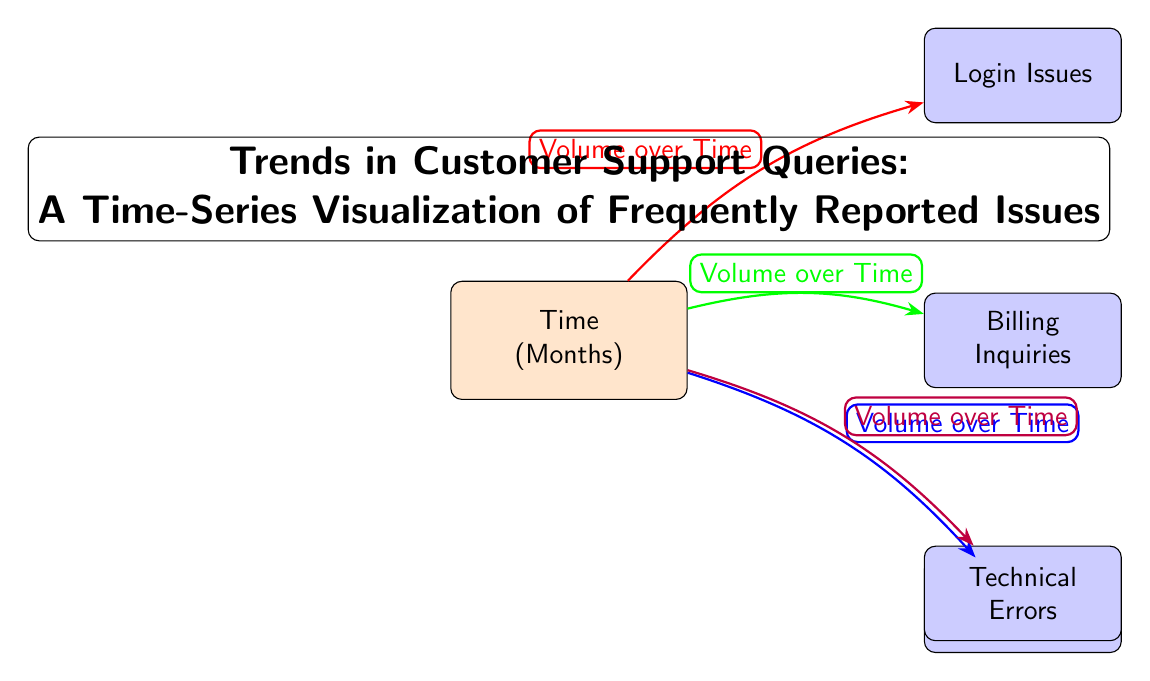What is the primary focus of the diagram? The diagram focuses on "Trends in Customer Support Queries," specifically visualizing the volume of frequently reported issues over time.
Answer: Trends in Customer Support Queries How many main issue categories are represented in the diagram? There are four main issue categories represented: Login Issues, Billing Inquiries, Feature Requests, and Technical Errors.
Answer: 4 Which issue is located directly above the "Time" node? The "Login Issues" node is located directly above the "Time" node, indicating it is a primary concern related to customer support queries.
Answer: Login Issues What color is used to represent "Feature Requests" in the diagram? The "Feature Requests" node is colored blue, differentiating it from other issues visually within the diagram.
Answer: Blue Which issue has the longest direct edge from the "Time" node based on the visual representation? The "Billing Inquiries" issue has a longer edge drawn from the "Time" node compared to others, indicating a possibly higher volume over time.
Answer: Billing Inquiries How is the relationship between "Time" and "Technical Errors" visualized in the diagram? The relationship is visualized with a purple arrow pointing from the "Time" node to "Technical Errors," indicating the volume of these errors over the specified time period.
Answer: Purple arrow If the volume of "Login Issues" increases, what might that imply about customer experiences? An increase in "Login Issues" may imply that users are facing more access issues, potentially affecting their overall satisfaction and the usability of the service.
Answer: More access issues Which edge color corresponds to "Billing Inquiries"? The edge color corresponding to "Billing Inquiries" is green, signifying that this category of customer queries has its own distinct visual representation.
Answer: Green Which issue is positioned below "Billing Inquiries" in the diagram? The "Technical Errors" issue is positioned below "Billing Inquiries," suggesting that the inquiries related to billing are prioritized over technical issues visually.
Answer: Technical Errors 